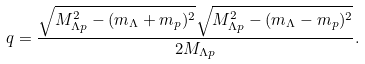Convert formula to latex. <formula><loc_0><loc_0><loc_500><loc_500>q = \frac { \sqrt { M _ { \Lambda { p } } ^ { 2 } - ( m _ { \Lambda } + m _ { p } ) ^ { 2 } } \sqrt { M _ { \Lambda { p } } ^ { 2 } - ( m _ { \Lambda } - m _ { p } ) ^ { 2 } } } { 2 M _ { \Lambda { p } } } .</formula> 